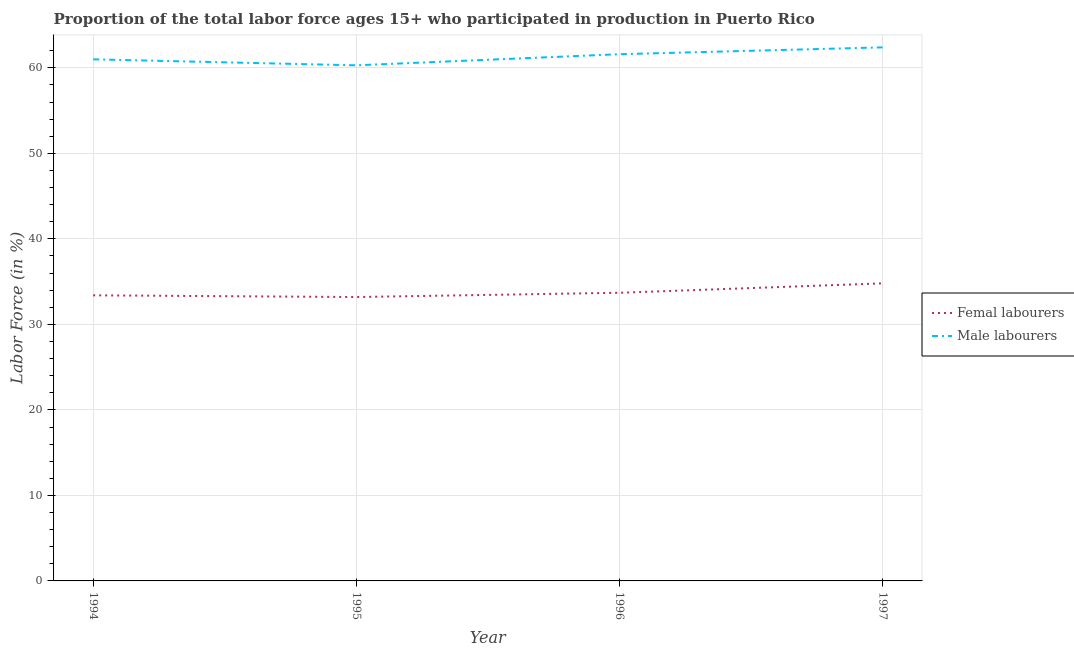How many different coloured lines are there?
Your response must be concise. 2. Is the number of lines equal to the number of legend labels?
Your response must be concise. Yes. What is the percentage of male labour force in 1997?
Give a very brief answer. 62.4. Across all years, what is the maximum percentage of male labour force?
Your answer should be very brief. 62.4. Across all years, what is the minimum percentage of female labor force?
Your response must be concise. 33.2. In which year was the percentage of female labor force minimum?
Give a very brief answer. 1995. What is the total percentage of male labour force in the graph?
Provide a succinct answer. 245.3. What is the difference between the percentage of male labour force in 1996 and that in 1997?
Make the answer very short. -0.8. What is the difference between the percentage of male labour force in 1994 and the percentage of female labor force in 1995?
Your answer should be very brief. 27.8. What is the average percentage of female labor force per year?
Make the answer very short. 33.78. In the year 1996, what is the difference between the percentage of male labour force and percentage of female labor force?
Offer a terse response. 27.9. What is the ratio of the percentage of female labor force in 1994 to that in 1996?
Your answer should be compact. 0.99. Is the percentage of male labour force in 1996 less than that in 1997?
Provide a short and direct response. Yes. What is the difference between the highest and the second highest percentage of female labor force?
Keep it short and to the point. 1.1. What is the difference between the highest and the lowest percentage of female labor force?
Keep it short and to the point. 1.6. In how many years, is the percentage of female labor force greater than the average percentage of female labor force taken over all years?
Give a very brief answer. 1. Is the sum of the percentage of male labour force in 1994 and 1997 greater than the maximum percentage of female labor force across all years?
Your response must be concise. Yes. Is the percentage of male labour force strictly less than the percentage of female labor force over the years?
Your answer should be compact. No. How many lines are there?
Provide a succinct answer. 2. How many years are there in the graph?
Your answer should be compact. 4. Does the graph contain any zero values?
Your answer should be very brief. No. Does the graph contain grids?
Make the answer very short. Yes. Where does the legend appear in the graph?
Make the answer very short. Center right. How are the legend labels stacked?
Your answer should be compact. Vertical. What is the title of the graph?
Offer a terse response. Proportion of the total labor force ages 15+ who participated in production in Puerto Rico. Does "Highest 20% of population" appear as one of the legend labels in the graph?
Make the answer very short. No. What is the label or title of the Y-axis?
Offer a terse response. Labor Force (in %). What is the Labor Force (in %) of Femal labourers in 1994?
Your answer should be compact. 33.4. What is the Labor Force (in %) in Femal labourers in 1995?
Provide a short and direct response. 33.2. What is the Labor Force (in %) in Male labourers in 1995?
Provide a short and direct response. 60.3. What is the Labor Force (in %) of Femal labourers in 1996?
Offer a terse response. 33.7. What is the Labor Force (in %) in Male labourers in 1996?
Make the answer very short. 61.6. What is the Labor Force (in %) in Femal labourers in 1997?
Offer a terse response. 34.8. What is the Labor Force (in %) in Male labourers in 1997?
Your answer should be very brief. 62.4. Across all years, what is the maximum Labor Force (in %) in Femal labourers?
Your answer should be compact. 34.8. Across all years, what is the maximum Labor Force (in %) in Male labourers?
Offer a very short reply. 62.4. Across all years, what is the minimum Labor Force (in %) of Femal labourers?
Provide a succinct answer. 33.2. Across all years, what is the minimum Labor Force (in %) in Male labourers?
Your answer should be very brief. 60.3. What is the total Labor Force (in %) in Femal labourers in the graph?
Provide a short and direct response. 135.1. What is the total Labor Force (in %) of Male labourers in the graph?
Give a very brief answer. 245.3. What is the difference between the Labor Force (in %) in Femal labourers in 1994 and that in 1996?
Your answer should be compact. -0.3. What is the difference between the Labor Force (in %) in Male labourers in 1994 and that in 1996?
Provide a succinct answer. -0.6. What is the difference between the Labor Force (in %) of Femal labourers in 1994 and that in 1997?
Provide a short and direct response. -1.4. What is the difference between the Labor Force (in %) in Male labourers in 1994 and that in 1997?
Offer a terse response. -1.4. What is the difference between the Labor Force (in %) of Femal labourers in 1995 and that in 1997?
Offer a terse response. -1.6. What is the difference between the Labor Force (in %) of Male labourers in 1996 and that in 1997?
Ensure brevity in your answer.  -0.8. What is the difference between the Labor Force (in %) in Femal labourers in 1994 and the Labor Force (in %) in Male labourers in 1995?
Give a very brief answer. -26.9. What is the difference between the Labor Force (in %) of Femal labourers in 1994 and the Labor Force (in %) of Male labourers in 1996?
Your answer should be compact. -28.2. What is the difference between the Labor Force (in %) of Femal labourers in 1994 and the Labor Force (in %) of Male labourers in 1997?
Provide a succinct answer. -29. What is the difference between the Labor Force (in %) in Femal labourers in 1995 and the Labor Force (in %) in Male labourers in 1996?
Provide a succinct answer. -28.4. What is the difference between the Labor Force (in %) of Femal labourers in 1995 and the Labor Force (in %) of Male labourers in 1997?
Offer a terse response. -29.2. What is the difference between the Labor Force (in %) in Femal labourers in 1996 and the Labor Force (in %) in Male labourers in 1997?
Make the answer very short. -28.7. What is the average Labor Force (in %) in Femal labourers per year?
Offer a terse response. 33.77. What is the average Labor Force (in %) of Male labourers per year?
Provide a short and direct response. 61.33. In the year 1994, what is the difference between the Labor Force (in %) in Femal labourers and Labor Force (in %) in Male labourers?
Offer a very short reply. -27.6. In the year 1995, what is the difference between the Labor Force (in %) of Femal labourers and Labor Force (in %) of Male labourers?
Make the answer very short. -27.1. In the year 1996, what is the difference between the Labor Force (in %) in Femal labourers and Labor Force (in %) in Male labourers?
Your response must be concise. -27.9. In the year 1997, what is the difference between the Labor Force (in %) of Femal labourers and Labor Force (in %) of Male labourers?
Ensure brevity in your answer.  -27.6. What is the ratio of the Labor Force (in %) of Femal labourers in 1994 to that in 1995?
Your answer should be very brief. 1.01. What is the ratio of the Labor Force (in %) in Male labourers in 1994 to that in 1995?
Give a very brief answer. 1.01. What is the ratio of the Labor Force (in %) of Male labourers in 1994 to that in 1996?
Your response must be concise. 0.99. What is the ratio of the Labor Force (in %) of Femal labourers in 1994 to that in 1997?
Make the answer very short. 0.96. What is the ratio of the Labor Force (in %) in Male labourers in 1994 to that in 1997?
Provide a short and direct response. 0.98. What is the ratio of the Labor Force (in %) of Femal labourers in 1995 to that in 1996?
Give a very brief answer. 0.99. What is the ratio of the Labor Force (in %) in Male labourers in 1995 to that in 1996?
Offer a terse response. 0.98. What is the ratio of the Labor Force (in %) of Femal labourers in 1995 to that in 1997?
Your answer should be compact. 0.95. What is the ratio of the Labor Force (in %) of Male labourers in 1995 to that in 1997?
Make the answer very short. 0.97. What is the ratio of the Labor Force (in %) in Femal labourers in 1996 to that in 1997?
Your answer should be very brief. 0.97. What is the ratio of the Labor Force (in %) of Male labourers in 1996 to that in 1997?
Provide a short and direct response. 0.99. What is the difference between the highest and the second highest Labor Force (in %) in Femal labourers?
Your answer should be very brief. 1.1. What is the difference between the highest and the lowest Labor Force (in %) of Male labourers?
Provide a succinct answer. 2.1. 